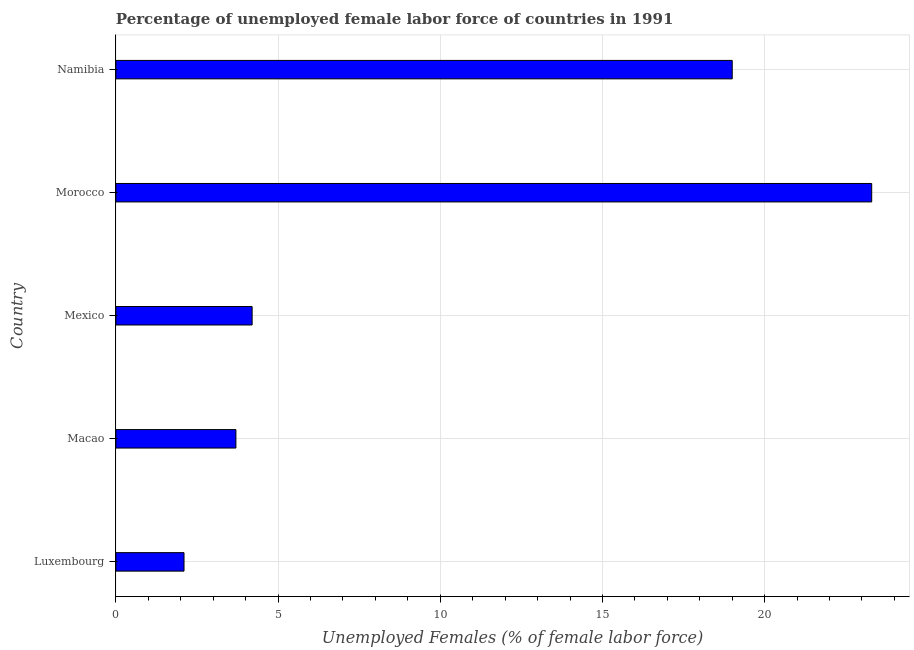Does the graph contain any zero values?
Provide a short and direct response. No. What is the title of the graph?
Make the answer very short. Percentage of unemployed female labor force of countries in 1991. What is the label or title of the X-axis?
Your response must be concise. Unemployed Females (% of female labor force). What is the label or title of the Y-axis?
Offer a very short reply. Country. What is the total unemployed female labour force in Macao?
Your response must be concise. 3.7. Across all countries, what is the maximum total unemployed female labour force?
Keep it short and to the point. 23.3. Across all countries, what is the minimum total unemployed female labour force?
Provide a succinct answer. 2.1. In which country was the total unemployed female labour force maximum?
Give a very brief answer. Morocco. In which country was the total unemployed female labour force minimum?
Your response must be concise. Luxembourg. What is the sum of the total unemployed female labour force?
Make the answer very short. 52.3. What is the difference between the total unemployed female labour force in Macao and Morocco?
Your response must be concise. -19.6. What is the average total unemployed female labour force per country?
Offer a very short reply. 10.46. What is the median total unemployed female labour force?
Give a very brief answer. 4.2. What is the ratio of the total unemployed female labour force in Macao to that in Mexico?
Your answer should be compact. 0.88. What is the difference between the highest and the second highest total unemployed female labour force?
Make the answer very short. 4.3. Is the sum of the total unemployed female labour force in Luxembourg and Macao greater than the maximum total unemployed female labour force across all countries?
Give a very brief answer. No. What is the difference between the highest and the lowest total unemployed female labour force?
Ensure brevity in your answer.  21.2. In how many countries, is the total unemployed female labour force greater than the average total unemployed female labour force taken over all countries?
Your answer should be compact. 2. Are all the bars in the graph horizontal?
Keep it short and to the point. Yes. How many countries are there in the graph?
Offer a terse response. 5. Are the values on the major ticks of X-axis written in scientific E-notation?
Offer a terse response. No. What is the Unemployed Females (% of female labor force) in Luxembourg?
Offer a terse response. 2.1. What is the Unemployed Females (% of female labor force) in Macao?
Offer a terse response. 3.7. What is the Unemployed Females (% of female labor force) in Mexico?
Your answer should be compact. 4.2. What is the Unemployed Females (% of female labor force) in Morocco?
Your answer should be very brief. 23.3. What is the Unemployed Females (% of female labor force) in Namibia?
Provide a succinct answer. 19. What is the difference between the Unemployed Females (% of female labor force) in Luxembourg and Morocco?
Provide a succinct answer. -21.2. What is the difference between the Unemployed Females (% of female labor force) in Luxembourg and Namibia?
Provide a short and direct response. -16.9. What is the difference between the Unemployed Females (% of female labor force) in Macao and Morocco?
Keep it short and to the point. -19.6. What is the difference between the Unemployed Females (% of female labor force) in Macao and Namibia?
Offer a terse response. -15.3. What is the difference between the Unemployed Females (% of female labor force) in Mexico and Morocco?
Make the answer very short. -19.1. What is the difference between the Unemployed Females (% of female labor force) in Mexico and Namibia?
Your answer should be very brief. -14.8. What is the ratio of the Unemployed Females (% of female labor force) in Luxembourg to that in Macao?
Offer a very short reply. 0.57. What is the ratio of the Unemployed Females (% of female labor force) in Luxembourg to that in Morocco?
Give a very brief answer. 0.09. What is the ratio of the Unemployed Females (% of female labor force) in Luxembourg to that in Namibia?
Make the answer very short. 0.11. What is the ratio of the Unemployed Females (% of female labor force) in Macao to that in Mexico?
Keep it short and to the point. 0.88. What is the ratio of the Unemployed Females (% of female labor force) in Macao to that in Morocco?
Your response must be concise. 0.16. What is the ratio of the Unemployed Females (% of female labor force) in Macao to that in Namibia?
Your response must be concise. 0.2. What is the ratio of the Unemployed Females (% of female labor force) in Mexico to that in Morocco?
Make the answer very short. 0.18. What is the ratio of the Unemployed Females (% of female labor force) in Mexico to that in Namibia?
Your response must be concise. 0.22. What is the ratio of the Unemployed Females (% of female labor force) in Morocco to that in Namibia?
Your response must be concise. 1.23. 